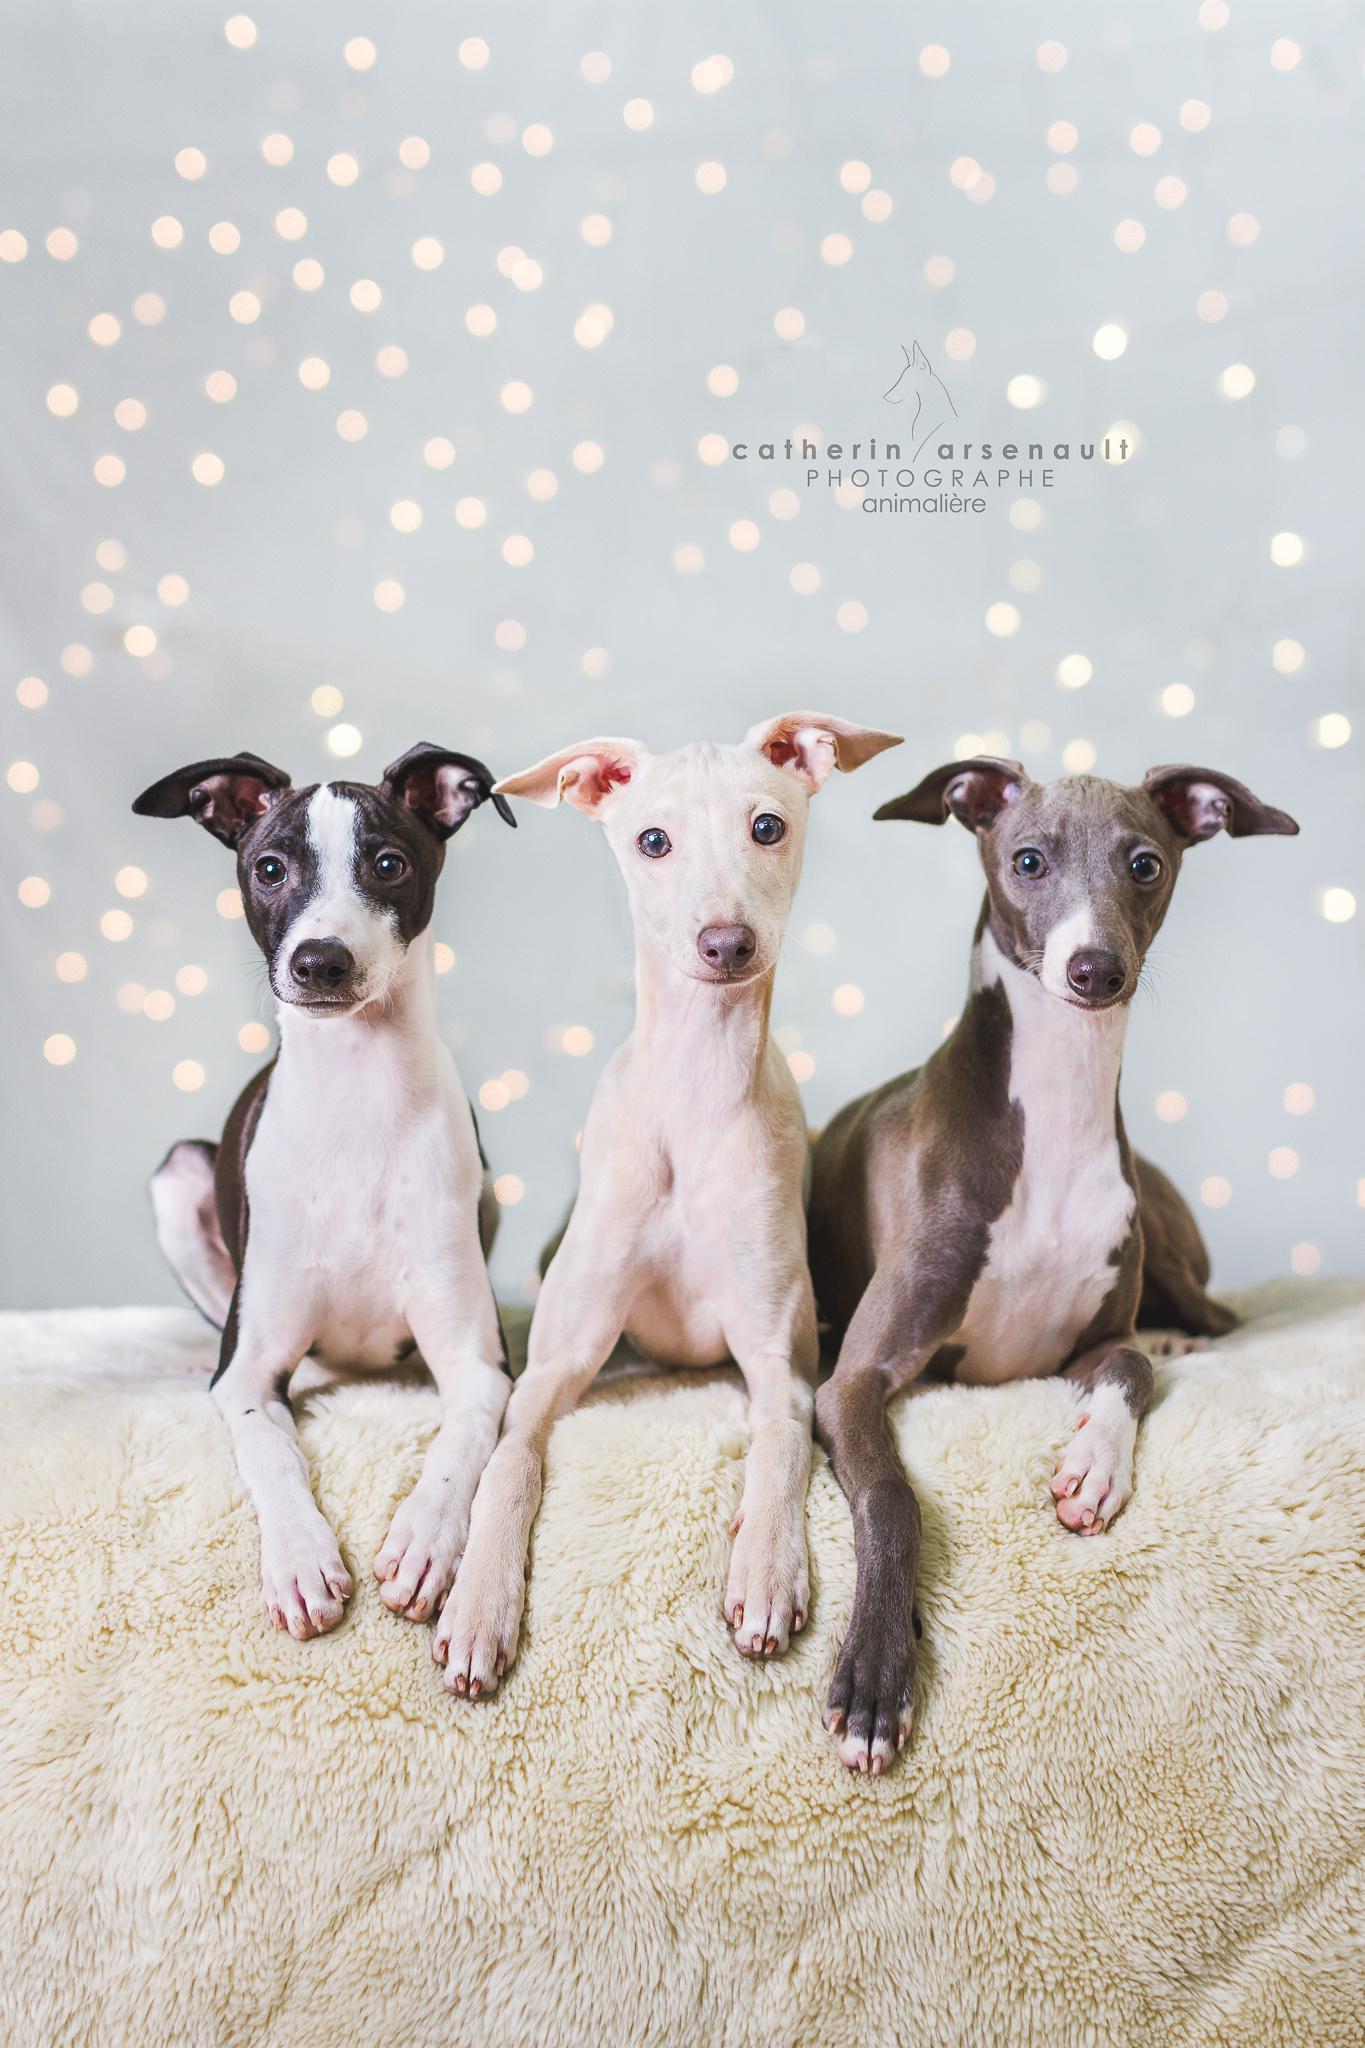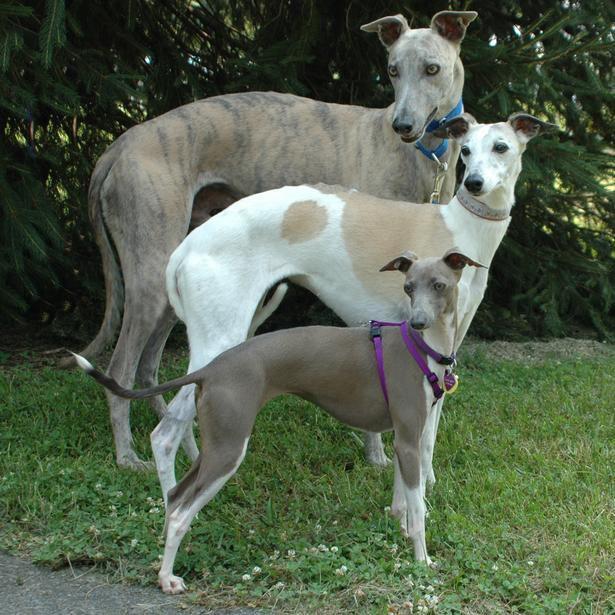The first image is the image on the left, the second image is the image on the right. Assess this claim about the two images: "There are six dogs in total.". Correct or not? Answer yes or no. Yes. The first image is the image on the left, the second image is the image on the right. Analyze the images presented: Is the assertion "Each image contains exactly three hounds, including one image of dogs posed in a horizontal row." valid? Answer yes or no. Yes. 